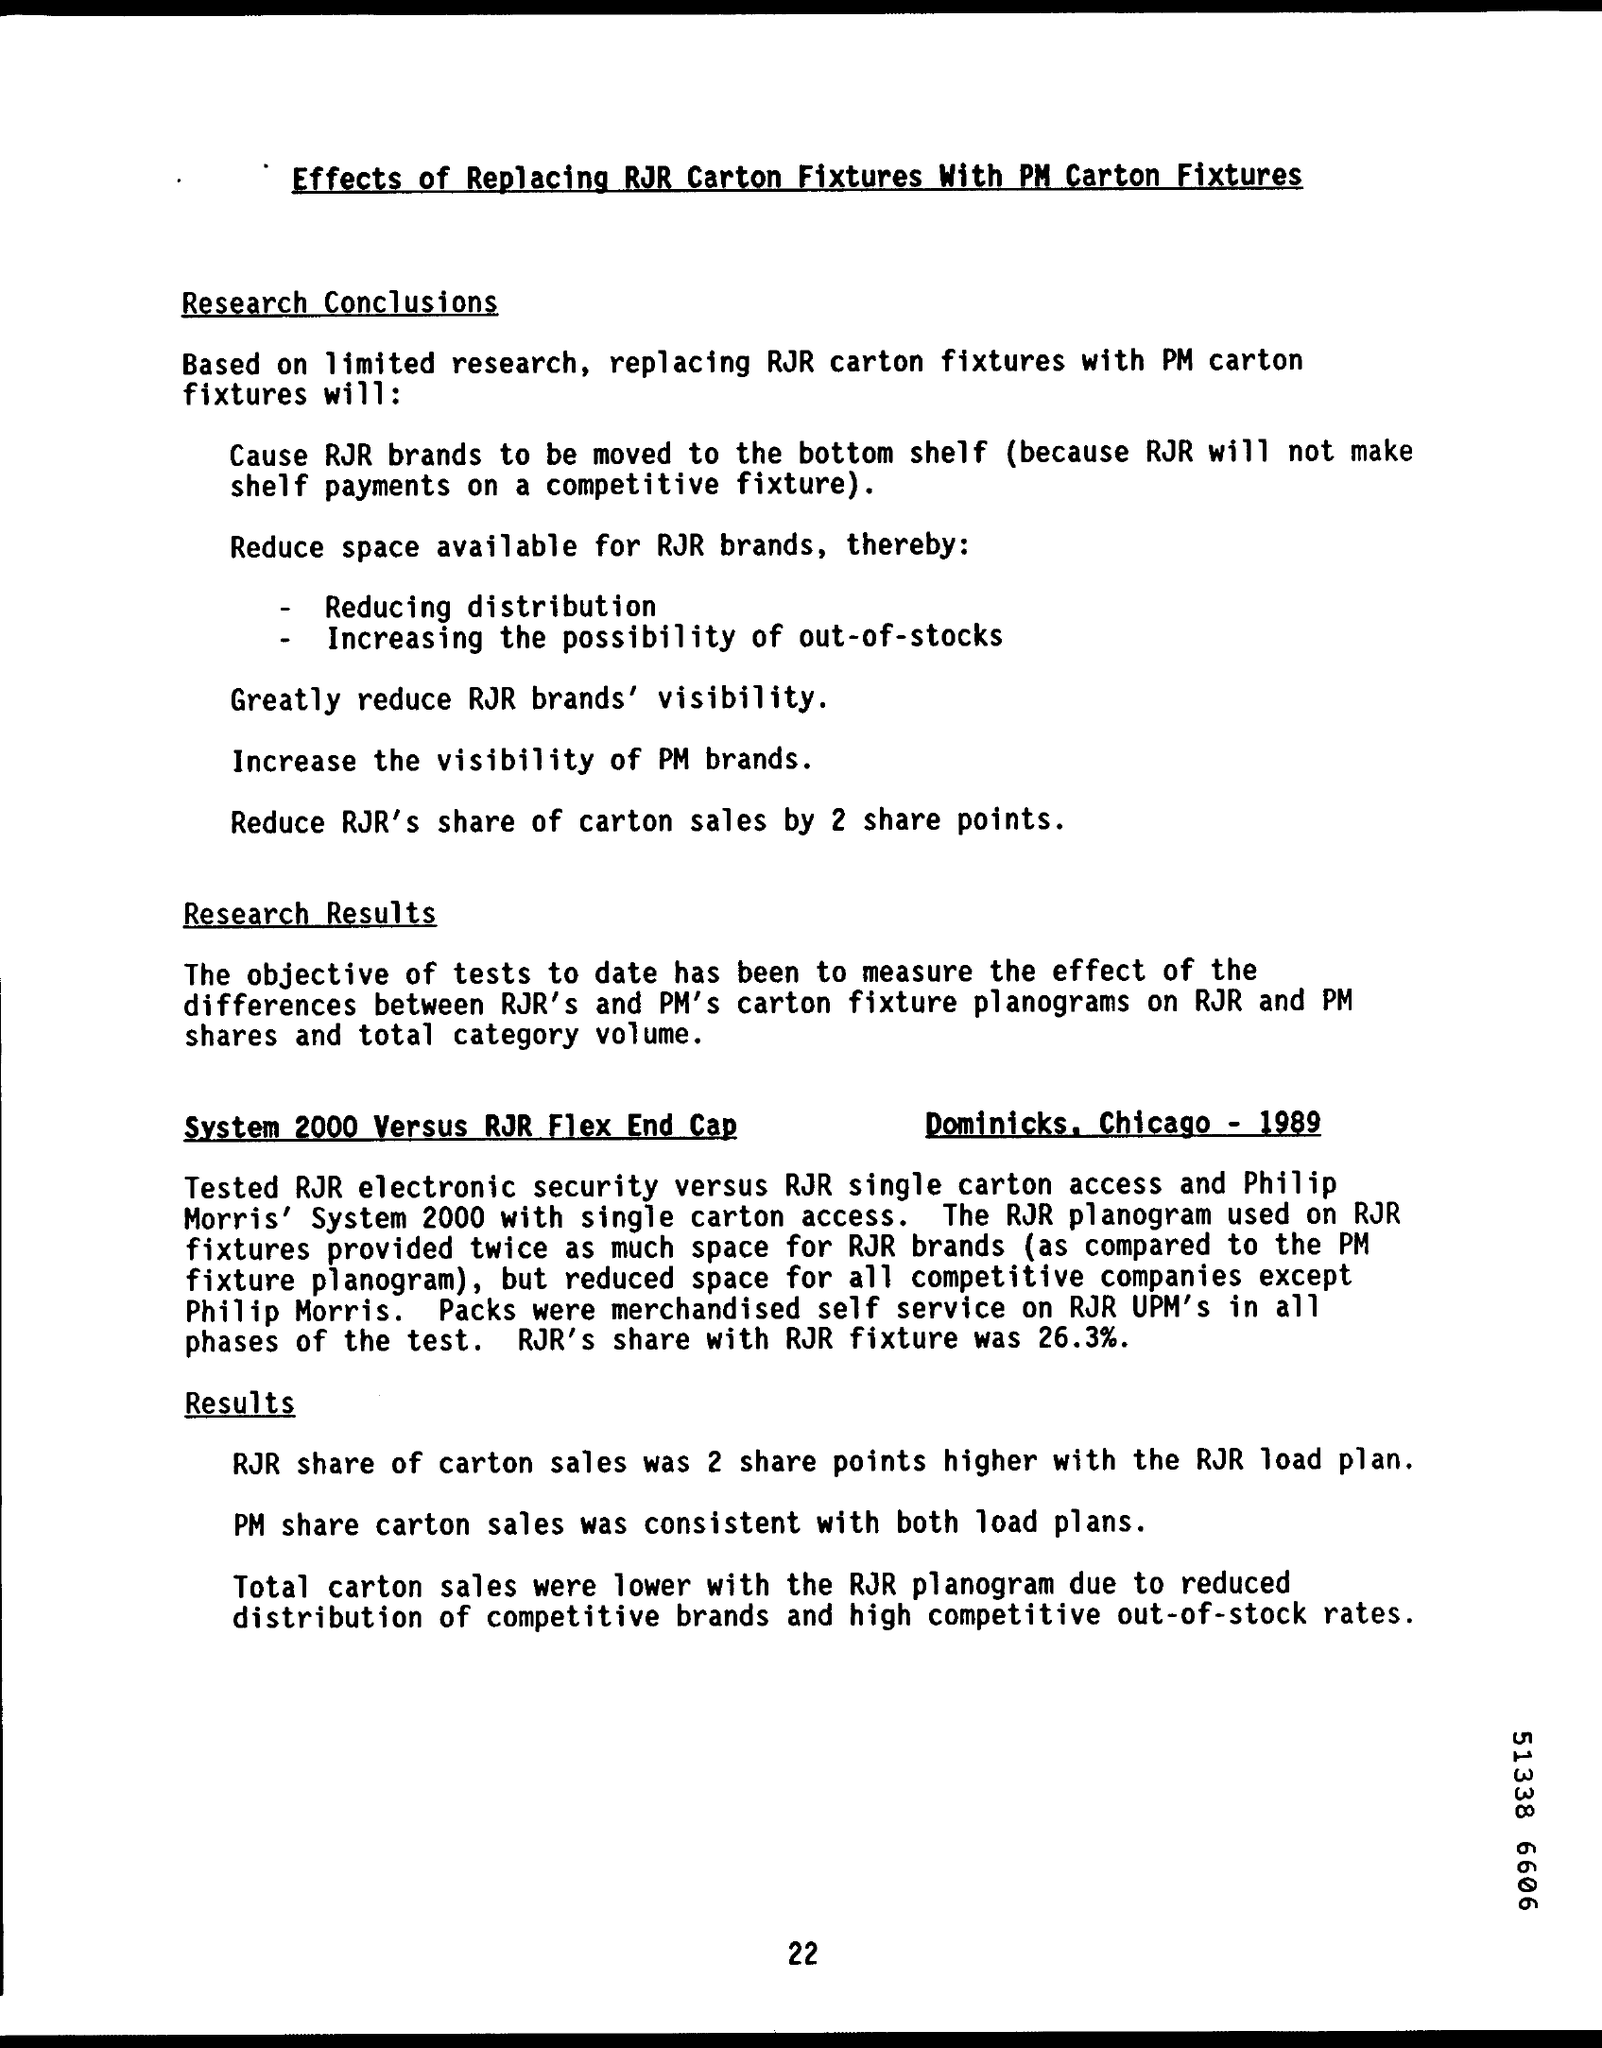List a handful of essential elements in this visual. RJR's share with RJR fixture was 26.3%. This document contains information on the effects of replacing RJR Carton fixtures with PM Carton fixtures. The page number on this document is 22. 